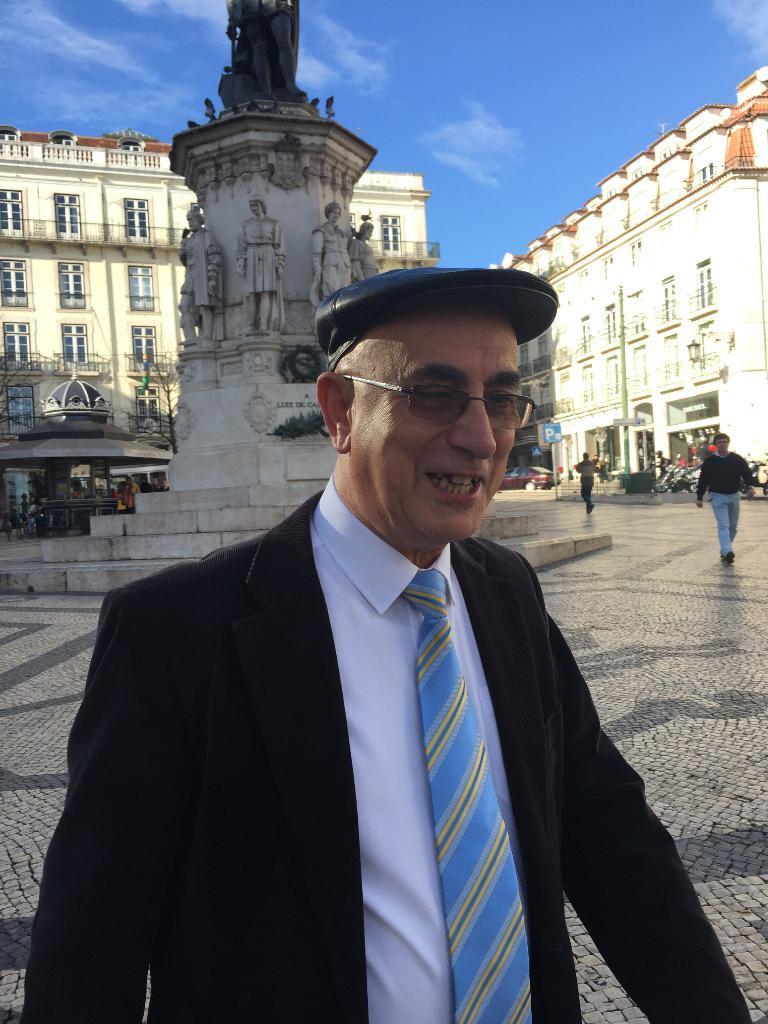Please provide a concise description of this image. In this image I can see a crowd on the road. In the background I can see buildings, shops, boards and statues. On the top I can see the sky. This image is taken on the road. 